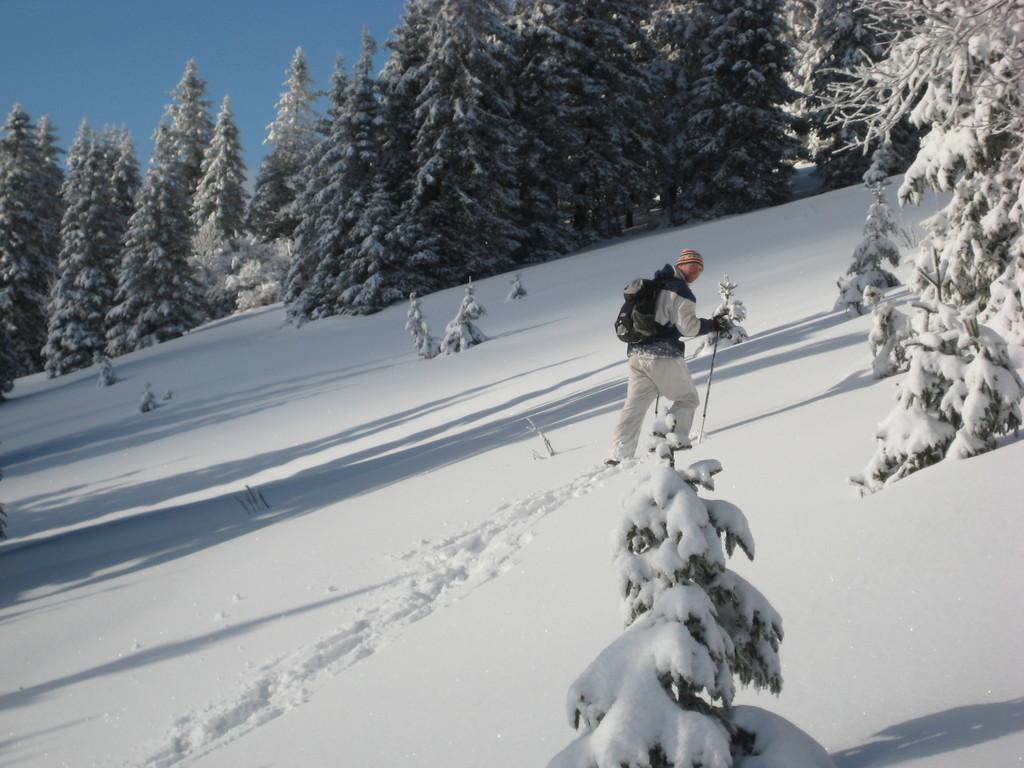How would you summarize this image in a sentence or two? In this picture I can observe a man walking on the snow. This man is holding a stick in his hand. I can observe some snow on the trees. In the background there is a sky. 